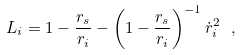<formula> <loc_0><loc_0><loc_500><loc_500>L _ { i } = 1 - \frac { r _ { s } } { r _ { i } } - \left ( 1 - \frac { r _ { s } } { r _ { i } } \right ) ^ { - 1 } \dot { r } _ { i } ^ { 2 } \ ,</formula> 